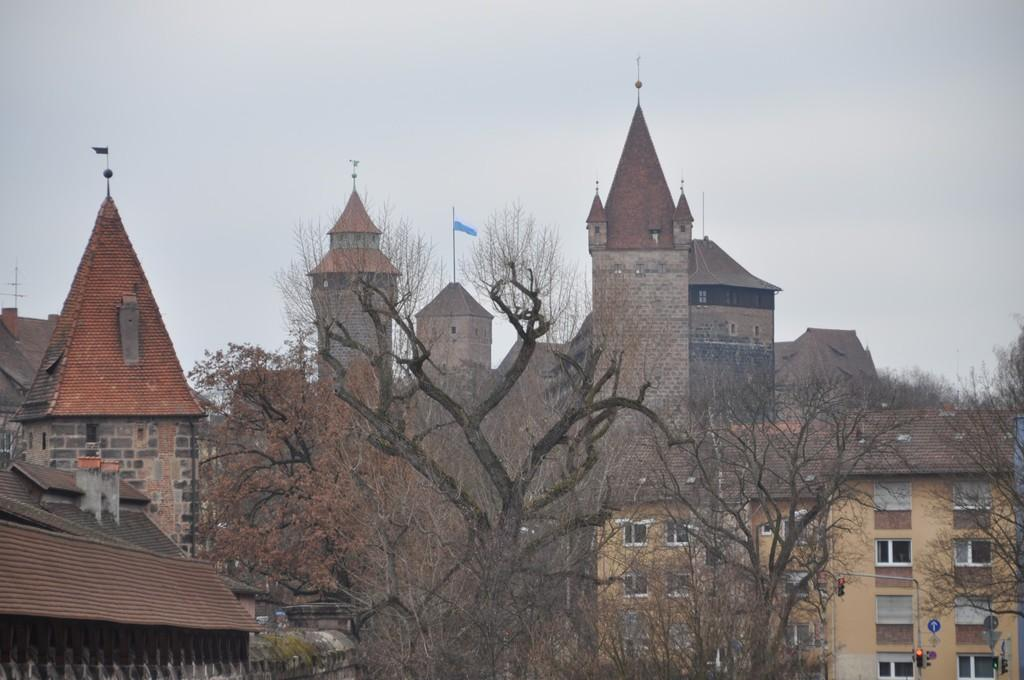What type of vegetation can be seen in the image? There are many trees in the image. What type of structures are present in the image? There are houses in the image. Are there any additional features on the houses? Flags are present on the top of the houses. What is the color of the sky in the image? The sky is blue in the image. Can you see a quill being used to write on a camera in the image? There is no quill or camera present in the image. What point is being made by the trees in the image? The trees in the image are not making any point; they are simply part of the natural landscape. 